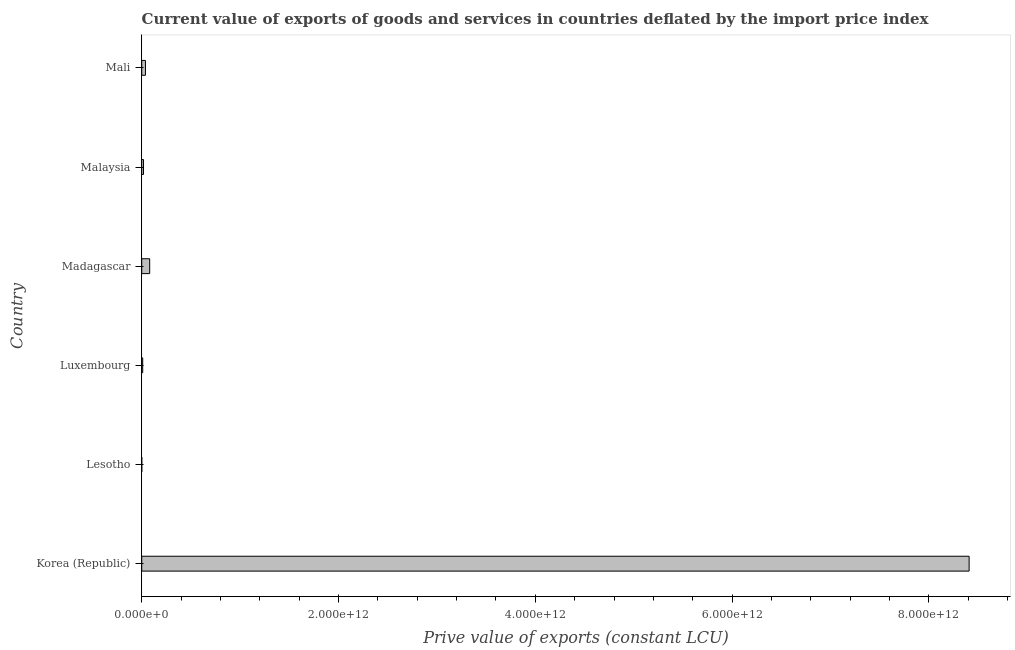Does the graph contain any zero values?
Make the answer very short. No. What is the title of the graph?
Keep it short and to the point. Current value of exports of goods and services in countries deflated by the import price index. What is the label or title of the X-axis?
Your response must be concise. Prive value of exports (constant LCU). What is the label or title of the Y-axis?
Offer a very short reply. Country. What is the price value of exports in Luxembourg?
Your response must be concise. 9.96e+09. Across all countries, what is the maximum price value of exports?
Make the answer very short. 8.41e+12. Across all countries, what is the minimum price value of exports?
Make the answer very short. 5.24e+08. In which country was the price value of exports minimum?
Offer a very short reply. Lesotho. What is the sum of the price value of exports?
Provide a succinct answer. 8.56e+12. What is the difference between the price value of exports in Luxembourg and Malaysia?
Offer a very short reply. -8.32e+09. What is the average price value of exports per country?
Provide a short and direct response. 1.43e+12. What is the median price value of exports?
Offer a very short reply. 2.81e+1. What is the ratio of the price value of exports in Luxembourg to that in Mali?
Ensure brevity in your answer.  0.26. What is the difference between the highest and the second highest price value of exports?
Keep it short and to the point. 8.33e+12. What is the difference between the highest and the lowest price value of exports?
Your answer should be compact. 8.41e+12. In how many countries, is the price value of exports greater than the average price value of exports taken over all countries?
Make the answer very short. 1. Are all the bars in the graph horizontal?
Provide a short and direct response. Yes. How many countries are there in the graph?
Offer a terse response. 6. What is the difference between two consecutive major ticks on the X-axis?
Your answer should be compact. 2.00e+12. What is the Prive value of exports (constant LCU) in Korea (Republic)?
Make the answer very short. 8.41e+12. What is the Prive value of exports (constant LCU) in Lesotho?
Offer a terse response. 5.24e+08. What is the Prive value of exports (constant LCU) of Luxembourg?
Your answer should be compact. 9.96e+09. What is the Prive value of exports (constant LCU) in Madagascar?
Provide a succinct answer. 8.09e+1. What is the Prive value of exports (constant LCU) in Malaysia?
Provide a short and direct response. 1.83e+1. What is the Prive value of exports (constant LCU) of Mali?
Your response must be concise. 3.79e+1. What is the difference between the Prive value of exports (constant LCU) in Korea (Republic) and Lesotho?
Your response must be concise. 8.41e+12. What is the difference between the Prive value of exports (constant LCU) in Korea (Republic) and Luxembourg?
Your response must be concise. 8.40e+12. What is the difference between the Prive value of exports (constant LCU) in Korea (Republic) and Madagascar?
Give a very brief answer. 8.33e+12. What is the difference between the Prive value of exports (constant LCU) in Korea (Republic) and Malaysia?
Offer a terse response. 8.39e+12. What is the difference between the Prive value of exports (constant LCU) in Korea (Republic) and Mali?
Offer a very short reply. 8.37e+12. What is the difference between the Prive value of exports (constant LCU) in Lesotho and Luxembourg?
Keep it short and to the point. -9.44e+09. What is the difference between the Prive value of exports (constant LCU) in Lesotho and Madagascar?
Provide a succinct answer. -8.04e+1. What is the difference between the Prive value of exports (constant LCU) in Lesotho and Malaysia?
Your response must be concise. -1.78e+1. What is the difference between the Prive value of exports (constant LCU) in Lesotho and Mali?
Ensure brevity in your answer.  -3.74e+1. What is the difference between the Prive value of exports (constant LCU) in Luxembourg and Madagascar?
Offer a terse response. -7.10e+1. What is the difference between the Prive value of exports (constant LCU) in Luxembourg and Malaysia?
Provide a short and direct response. -8.32e+09. What is the difference between the Prive value of exports (constant LCU) in Luxembourg and Mali?
Give a very brief answer. -2.79e+1. What is the difference between the Prive value of exports (constant LCU) in Madagascar and Malaysia?
Keep it short and to the point. 6.27e+1. What is the difference between the Prive value of exports (constant LCU) in Madagascar and Mali?
Offer a terse response. 4.30e+1. What is the difference between the Prive value of exports (constant LCU) in Malaysia and Mali?
Offer a terse response. -1.96e+1. What is the ratio of the Prive value of exports (constant LCU) in Korea (Republic) to that in Lesotho?
Provide a short and direct response. 1.60e+04. What is the ratio of the Prive value of exports (constant LCU) in Korea (Republic) to that in Luxembourg?
Offer a very short reply. 844.3. What is the ratio of the Prive value of exports (constant LCU) in Korea (Republic) to that in Madagascar?
Keep it short and to the point. 103.91. What is the ratio of the Prive value of exports (constant LCU) in Korea (Republic) to that in Malaysia?
Offer a very short reply. 460.13. What is the ratio of the Prive value of exports (constant LCU) in Korea (Republic) to that in Mali?
Keep it short and to the point. 221.84. What is the ratio of the Prive value of exports (constant LCU) in Lesotho to that in Luxembourg?
Your answer should be compact. 0.05. What is the ratio of the Prive value of exports (constant LCU) in Lesotho to that in Madagascar?
Provide a short and direct response. 0.01. What is the ratio of the Prive value of exports (constant LCU) in Lesotho to that in Malaysia?
Give a very brief answer. 0.03. What is the ratio of the Prive value of exports (constant LCU) in Lesotho to that in Mali?
Your response must be concise. 0.01. What is the ratio of the Prive value of exports (constant LCU) in Luxembourg to that in Madagascar?
Your response must be concise. 0.12. What is the ratio of the Prive value of exports (constant LCU) in Luxembourg to that in Malaysia?
Give a very brief answer. 0.55. What is the ratio of the Prive value of exports (constant LCU) in Luxembourg to that in Mali?
Give a very brief answer. 0.26. What is the ratio of the Prive value of exports (constant LCU) in Madagascar to that in Malaysia?
Provide a short and direct response. 4.43. What is the ratio of the Prive value of exports (constant LCU) in Madagascar to that in Mali?
Your answer should be compact. 2.13. What is the ratio of the Prive value of exports (constant LCU) in Malaysia to that in Mali?
Your response must be concise. 0.48. 